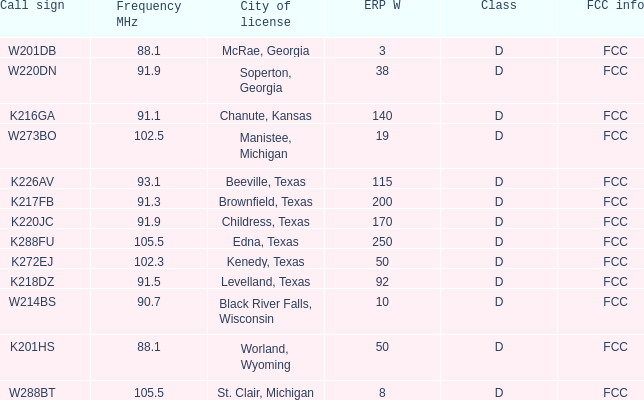What is City of License, when ERP W is greater than 3, and when Call Sign is K218DZ? Levelland, Texas. 